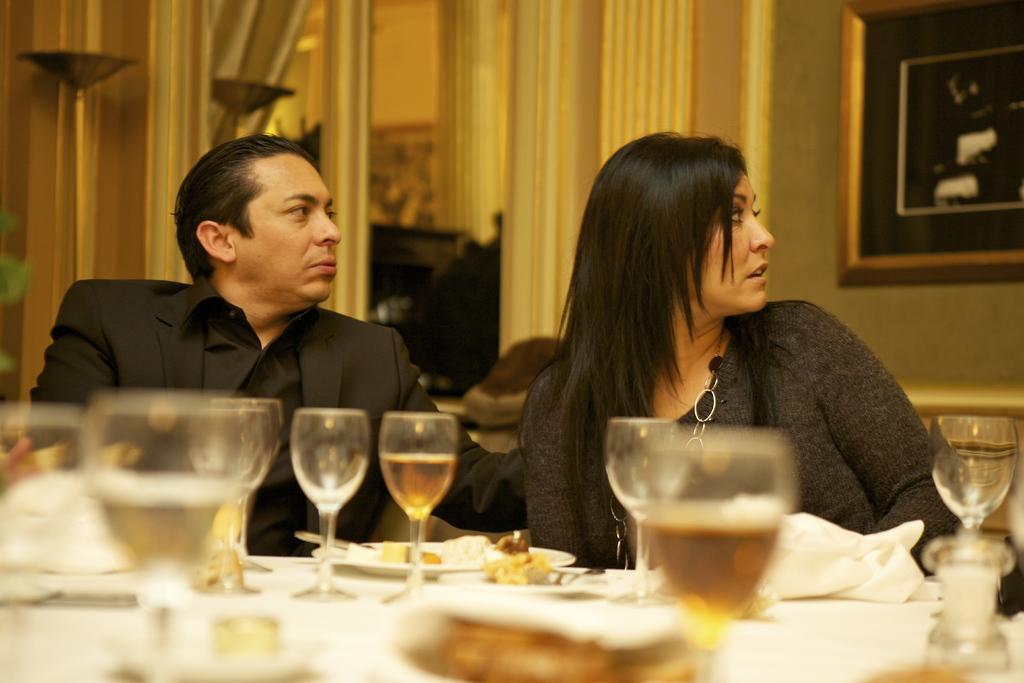Could you give a brief overview of what you see in this image? This 2 persons are sitting on a chair. In-front of this 2 persons there is a table. On a table there are glasses, plates and food. Background on a wall there is a picture. This woman wore black t-shirt. This man wore black suit. 